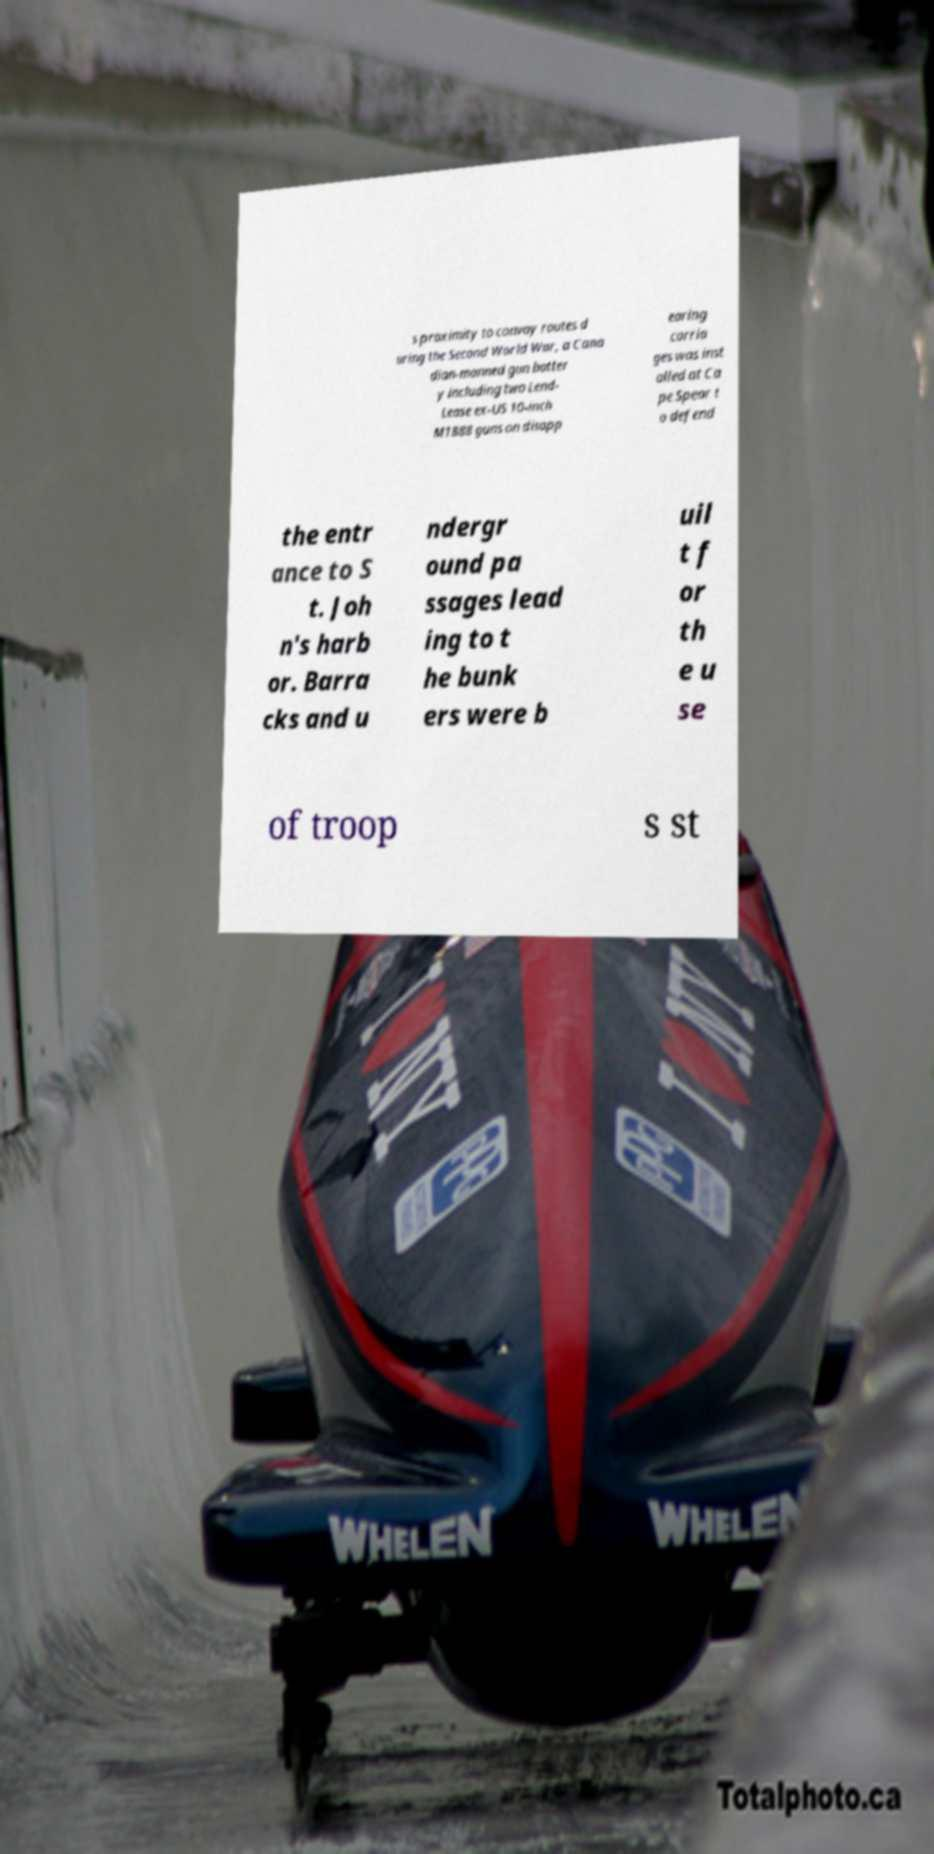Can you read and provide the text displayed in the image?This photo seems to have some interesting text. Can you extract and type it out for me? s proximity to convoy routes d uring the Second World War, a Cana dian-manned gun batter y including two Lend- Lease ex-US 10-inch M1888 guns on disapp earing carria ges was inst alled at Ca pe Spear t o defend the entr ance to S t. Joh n's harb or. Barra cks and u ndergr ound pa ssages lead ing to t he bunk ers were b uil t f or th e u se of troop s st 